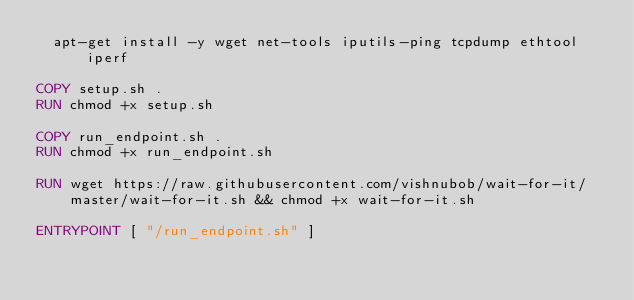<code> <loc_0><loc_0><loc_500><loc_500><_Dockerfile_>  apt-get install -y wget net-tools iputils-ping tcpdump ethtool iperf

COPY setup.sh .
RUN chmod +x setup.sh

COPY run_endpoint.sh .
RUN chmod +x run_endpoint.sh

RUN wget https://raw.githubusercontent.com/vishnubob/wait-for-it/master/wait-for-it.sh && chmod +x wait-for-it.sh

ENTRYPOINT [ "/run_endpoint.sh" ]
</code> 